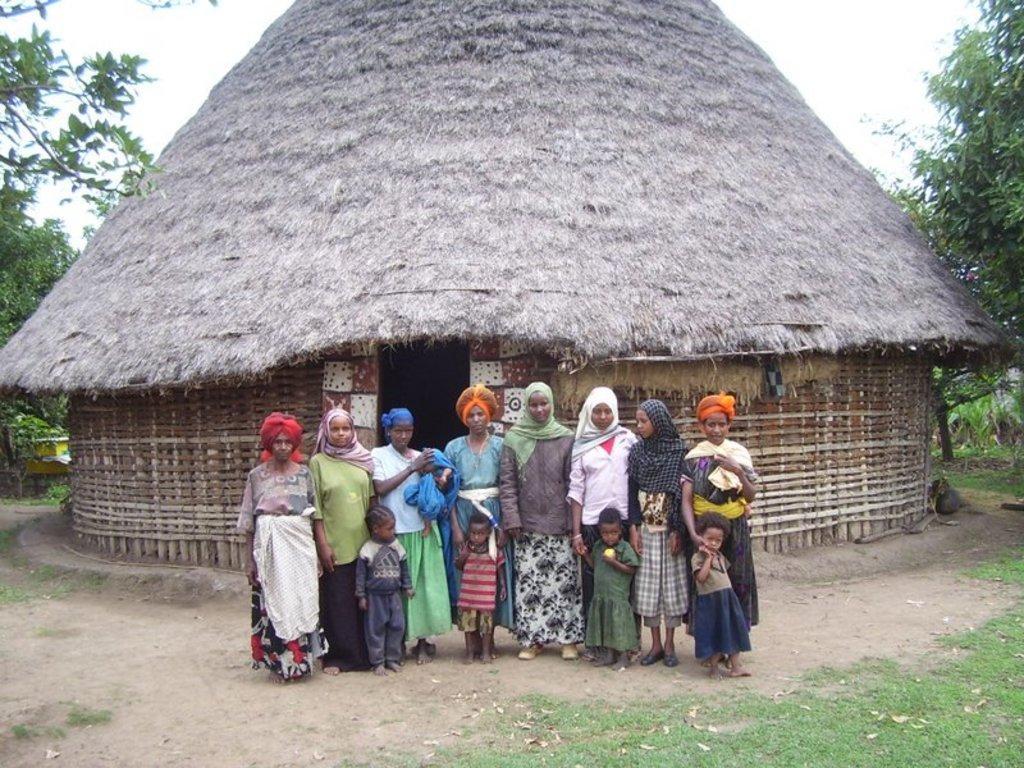In one or two sentences, can you explain what this image depicts? In this picture we can see some people are standing in the front, there is a hut in the middle, on the right side and left side we can see trees, at the bottom there is grass, there is the sky at the top of the picture. 